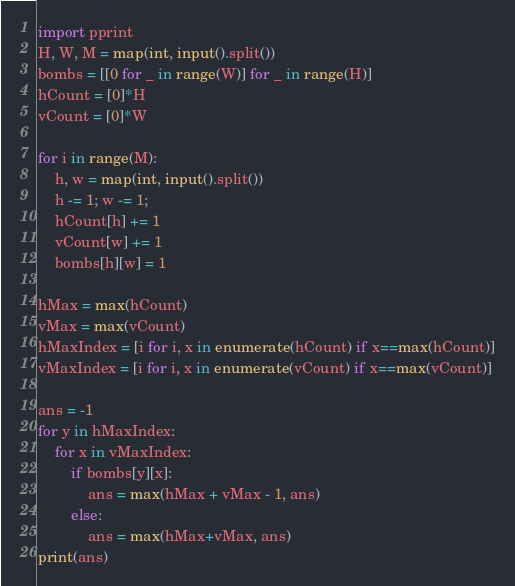Convert code to text. <code><loc_0><loc_0><loc_500><loc_500><_Python_>import pprint
H, W, M = map(int, input().split())
bombs = [[0 for _ in range(W)] for _ in range(H)]
hCount = [0]*H
vCount = [0]*W

for i in range(M):
    h, w = map(int, input().split())
    h -= 1; w -= 1;
    hCount[h] += 1
    vCount[w] += 1
    bombs[h][w] = 1

hMax = max(hCount)
vMax = max(vCount)
hMaxIndex = [i for i, x in enumerate(hCount) if x==max(hCount)]
vMaxIndex = [i for i, x in enumerate(vCount) if x==max(vCount)]

ans = -1
for y in hMaxIndex:
    for x in vMaxIndex:
        if bombs[y][x]:
            ans = max(hMax + vMax - 1, ans)
        else:
            ans = max(hMax+vMax, ans)
print(ans)
</code> 